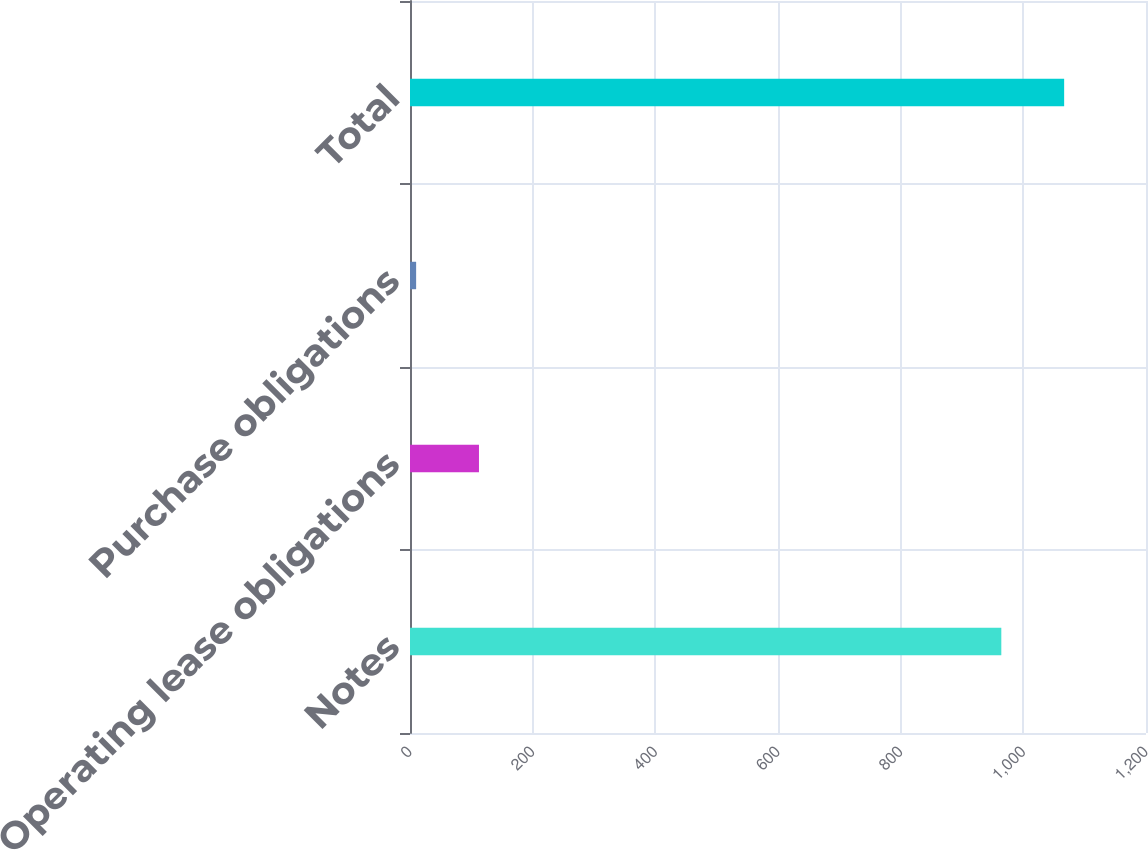Convert chart to OTSL. <chart><loc_0><loc_0><loc_500><loc_500><bar_chart><fcel>Notes<fcel>Operating lease obligations<fcel>Purchase obligations<fcel>Total<nl><fcel>964.1<fcel>112.45<fcel>10<fcel>1066.55<nl></chart> 